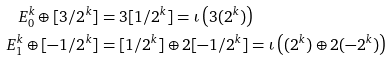<formula> <loc_0><loc_0><loc_500><loc_500>E ^ { k } _ { 0 } \oplus [ 3 / 2 ^ { k } ] & = 3 [ 1 / 2 ^ { k } ] = \iota \left ( 3 ( 2 ^ { k } ) \right ) \\ E ^ { k } _ { 1 } \oplus [ - 1 / 2 ^ { k } ] & = [ 1 / 2 ^ { k } ] \oplus 2 [ - 1 / 2 ^ { k } ] = \iota \left ( ( 2 ^ { k } ) \oplus 2 ( - 2 ^ { k } ) \right )</formula> 